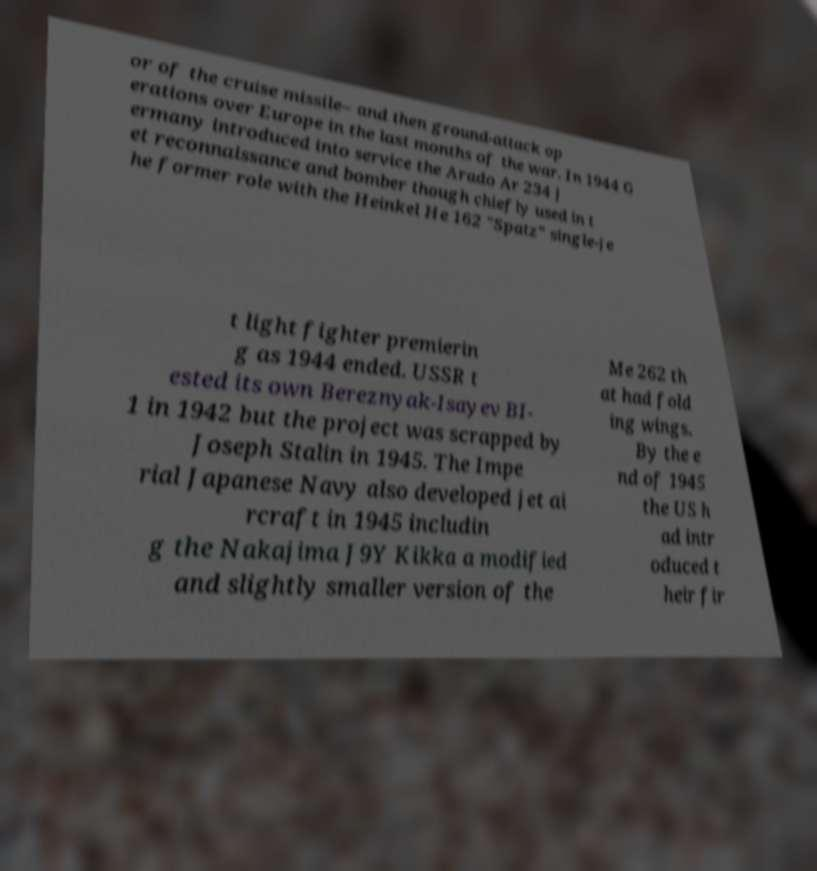I need the written content from this picture converted into text. Can you do that? or of the cruise missile– and then ground-attack op erations over Europe in the last months of the war. In 1944 G ermany introduced into service the Arado Ar 234 j et reconnaissance and bomber though chiefly used in t he former role with the Heinkel He 162 "Spatz" single-je t light fighter premierin g as 1944 ended. USSR t ested its own Bereznyak-Isayev BI- 1 in 1942 but the project was scrapped by Joseph Stalin in 1945. The Impe rial Japanese Navy also developed jet ai rcraft in 1945 includin g the Nakajima J9Y Kikka a modified and slightly smaller version of the Me 262 th at had fold ing wings. By the e nd of 1945 the US h ad intr oduced t heir fir 